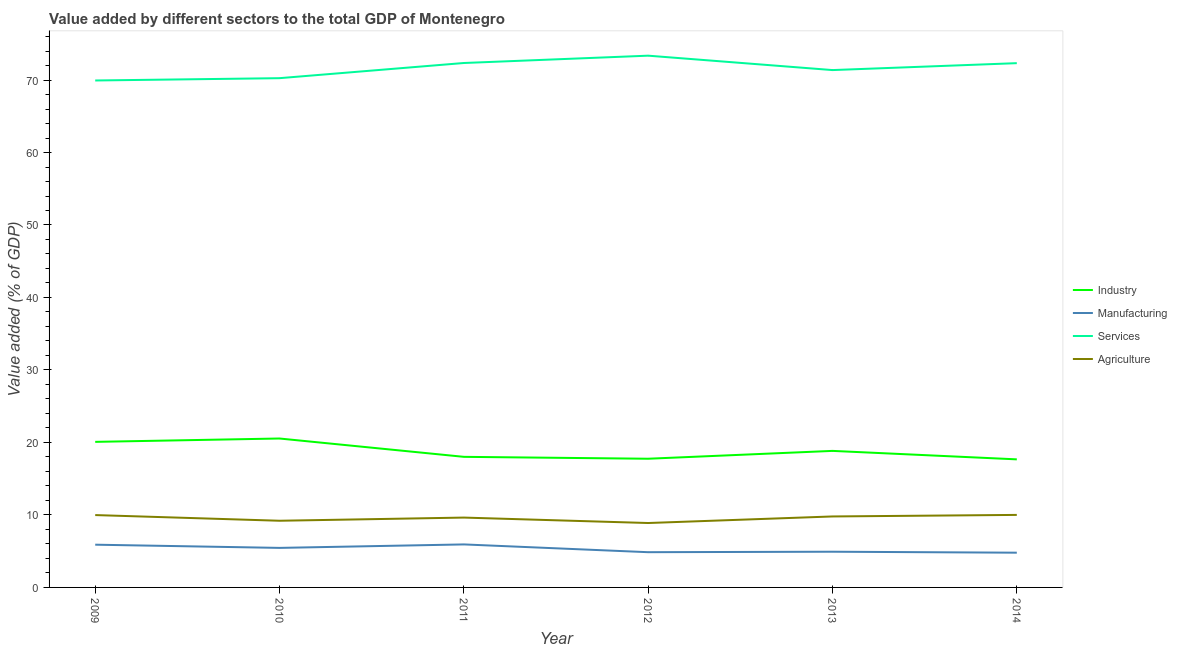What is the value added by industrial sector in 2012?
Keep it short and to the point. 17.75. Across all years, what is the maximum value added by services sector?
Make the answer very short. 73.36. Across all years, what is the minimum value added by services sector?
Offer a very short reply. 69.94. In which year was the value added by services sector minimum?
Give a very brief answer. 2009. What is the total value added by agricultural sector in the graph?
Your answer should be very brief. 57.5. What is the difference between the value added by industrial sector in 2009 and that in 2010?
Your answer should be compact. -0.46. What is the difference between the value added by industrial sector in 2010 and the value added by services sector in 2013?
Provide a short and direct response. -50.83. What is the average value added by services sector per year?
Your response must be concise. 71.6. In the year 2011, what is the difference between the value added by services sector and value added by manufacturing sector?
Ensure brevity in your answer.  66.42. In how many years, is the value added by agricultural sector greater than 58 %?
Your answer should be compact. 0. What is the ratio of the value added by manufacturing sector in 2012 to that in 2014?
Provide a succinct answer. 1.01. Is the value added by industrial sector in 2011 less than that in 2013?
Provide a succinct answer. Yes. What is the difference between the highest and the second highest value added by industrial sector?
Your answer should be very brief. 0.46. What is the difference between the highest and the lowest value added by agricultural sector?
Provide a short and direct response. 1.12. In how many years, is the value added by services sector greater than the average value added by services sector taken over all years?
Offer a terse response. 3. Is the sum of the value added by agricultural sector in 2010 and 2011 greater than the maximum value added by services sector across all years?
Provide a succinct answer. No. Does the value added by agricultural sector monotonically increase over the years?
Offer a very short reply. No. Is the value added by manufacturing sector strictly greater than the value added by industrial sector over the years?
Offer a very short reply. No. How many years are there in the graph?
Ensure brevity in your answer.  6. Are the values on the major ticks of Y-axis written in scientific E-notation?
Provide a succinct answer. No. Does the graph contain grids?
Provide a succinct answer. No. Where does the legend appear in the graph?
Provide a short and direct response. Center right. What is the title of the graph?
Make the answer very short. Value added by different sectors to the total GDP of Montenegro. What is the label or title of the Y-axis?
Offer a terse response. Value added (% of GDP). What is the Value added (% of GDP) of Industry in 2009?
Provide a succinct answer. 20.08. What is the Value added (% of GDP) in Manufacturing in 2009?
Offer a very short reply. 5.9. What is the Value added (% of GDP) in Services in 2009?
Offer a terse response. 69.94. What is the Value added (% of GDP) in Agriculture in 2009?
Your answer should be compact. 9.98. What is the Value added (% of GDP) in Industry in 2010?
Make the answer very short. 20.54. What is the Value added (% of GDP) in Manufacturing in 2010?
Your answer should be very brief. 5.45. What is the Value added (% of GDP) in Services in 2010?
Your answer should be compact. 70.26. What is the Value added (% of GDP) of Agriculture in 2010?
Ensure brevity in your answer.  9.2. What is the Value added (% of GDP) in Industry in 2011?
Offer a very short reply. 18.02. What is the Value added (% of GDP) in Manufacturing in 2011?
Your answer should be compact. 5.93. What is the Value added (% of GDP) of Services in 2011?
Your response must be concise. 72.35. What is the Value added (% of GDP) in Agriculture in 2011?
Provide a succinct answer. 9.64. What is the Value added (% of GDP) of Industry in 2012?
Your response must be concise. 17.75. What is the Value added (% of GDP) in Manufacturing in 2012?
Offer a very short reply. 4.86. What is the Value added (% of GDP) in Services in 2012?
Provide a succinct answer. 73.36. What is the Value added (% of GDP) in Agriculture in 2012?
Your answer should be compact. 8.89. What is the Value added (% of GDP) of Industry in 2013?
Offer a very short reply. 18.84. What is the Value added (% of GDP) of Manufacturing in 2013?
Offer a very short reply. 4.93. What is the Value added (% of GDP) of Services in 2013?
Ensure brevity in your answer.  71.37. What is the Value added (% of GDP) of Agriculture in 2013?
Keep it short and to the point. 9.79. What is the Value added (% of GDP) in Industry in 2014?
Keep it short and to the point. 17.67. What is the Value added (% of GDP) of Manufacturing in 2014?
Offer a very short reply. 4.79. What is the Value added (% of GDP) of Services in 2014?
Your answer should be compact. 72.33. What is the Value added (% of GDP) in Agriculture in 2014?
Provide a short and direct response. 10.01. Across all years, what is the maximum Value added (% of GDP) in Industry?
Make the answer very short. 20.54. Across all years, what is the maximum Value added (% of GDP) in Manufacturing?
Make the answer very short. 5.93. Across all years, what is the maximum Value added (% of GDP) in Services?
Keep it short and to the point. 73.36. Across all years, what is the maximum Value added (% of GDP) in Agriculture?
Provide a succinct answer. 10.01. Across all years, what is the minimum Value added (% of GDP) of Industry?
Your answer should be compact. 17.67. Across all years, what is the minimum Value added (% of GDP) of Manufacturing?
Offer a terse response. 4.79. Across all years, what is the minimum Value added (% of GDP) of Services?
Give a very brief answer. 69.94. Across all years, what is the minimum Value added (% of GDP) of Agriculture?
Provide a short and direct response. 8.89. What is the total Value added (% of GDP) in Industry in the graph?
Offer a terse response. 112.9. What is the total Value added (% of GDP) of Manufacturing in the graph?
Give a very brief answer. 31.86. What is the total Value added (% of GDP) in Services in the graph?
Offer a terse response. 429.6. What is the total Value added (% of GDP) in Agriculture in the graph?
Your response must be concise. 57.5. What is the difference between the Value added (% of GDP) in Industry in 2009 and that in 2010?
Make the answer very short. -0.46. What is the difference between the Value added (% of GDP) of Manufacturing in 2009 and that in 2010?
Your answer should be compact. 0.44. What is the difference between the Value added (% of GDP) of Services in 2009 and that in 2010?
Ensure brevity in your answer.  -0.32. What is the difference between the Value added (% of GDP) of Agriculture in 2009 and that in 2010?
Ensure brevity in your answer.  0.78. What is the difference between the Value added (% of GDP) in Industry in 2009 and that in 2011?
Your answer should be compact. 2.07. What is the difference between the Value added (% of GDP) of Manufacturing in 2009 and that in 2011?
Give a very brief answer. -0.04. What is the difference between the Value added (% of GDP) in Services in 2009 and that in 2011?
Provide a succinct answer. -2.41. What is the difference between the Value added (% of GDP) in Agriculture in 2009 and that in 2011?
Your answer should be compact. 0.35. What is the difference between the Value added (% of GDP) of Industry in 2009 and that in 2012?
Ensure brevity in your answer.  2.33. What is the difference between the Value added (% of GDP) of Manufacturing in 2009 and that in 2012?
Make the answer very short. 1.04. What is the difference between the Value added (% of GDP) in Services in 2009 and that in 2012?
Give a very brief answer. -3.42. What is the difference between the Value added (% of GDP) of Agriculture in 2009 and that in 2012?
Offer a terse response. 1.1. What is the difference between the Value added (% of GDP) in Industry in 2009 and that in 2013?
Provide a short and direct response. 1.24. What is the difference between the Value added (% of GDP) in Manufacturing in 2009 and that in 2013?
Make the answer very short. 0.97. What is the difference between the Value added (% of GDP) of Services in 2009 and that in 2013?
Your answer should be compact. -1.44. What is the difference between the Value added (% of GDP) in Agriculture in 2009 and that in 2013?
Provide a succinct answer. 0.19. What is the difference between the Value added (% of GDP) of Industry in 2009 and that in 2014?
Your response must be concise. 2.41. What is the difference between the Value added (% of GDP) of Manufacturing in 2009 and that in 2014?
Provide a succinct answer. 1.1. What is the difference between the Value added (% of GDP) in Services in 2009 and that in 2014?
Your answer should be compact. -2.39. What is the difference between the Value added (% of GDP) of Agriculture in 2009 and that in 2014?
Your answer should be compact. -0.02. What is the difference between the Value added (% of GDP) in Industry in 2010 and that in 2011?
Give a very brief answer. 2.53. What is the difference between the Value added (% of GDP) of Manufacturing in 2010 and that in 2011?
Ensure brevity in your answer.  -0.48. What is the difference between the Value added (% of GDP) in Services in 2010 and that in 2011?
Provide a succinct answer. -2.09. What is the difference between the Value added (% of GDP) in Agriculture in 2010 and that in 2011?
Your answer should be compact. -0.44. What is the difference between the Value added (% of GDP) in Industry in 2010 and that in 2012?
Your response must be concise. 2.79. What is the difference between the Value added (% of GDP) of Manufacturing in 2010 and that in 2012?
Offer a very short reply. 0.59. What is the difference between the Value added (% of GDP) in Services in 2010 and that in 2012?
Your answer should be very brief. -3.1. What is the difference between the Value added (% of GDP) of Agriculture in 2010 and that in 2012?
Your response must be concise. 0.31. What is the difference between the Value added (% of GDP) of Industry in 2010 and that in 2013?
Keep it short and to the point. 1.71. What is the difference between the Value added (% of GDP) in Manufacturing in 2010 and that in 2013?
Ensure brevity in your answer.  0.53. What is the difference between the Value added (% of GDP) in Services in 2010 and that in 2013?
Provide a succinct answer. -1.12. What is the difference between the Value added (% of GDP) of Agriculture in 2010 and that in 2013?
Make the answer very short. -0.59. What is the difference between the Value added (% of GDP) of Industry in 2010 and that in 2014?
Keep it short and to the point. 2.88. What is the difference between the Value added (% of GDP) of Manufacturing in 2010 and that in 2014?
Offer a very short reply. 0.66. What is the difference between the Value added (% of GDP) in Services in 2010 and that in 2014?
Ensure brevity in your answer.  -2.07. What is the difference between the Value added (% of GDP) in Agriculture in 2010 and that in 2014?
Offer a very short reply. -0.81. What is the difference between the Value added (% of GDP) in Industry in 2011 and that in 2012?
Your response must be concise. 0.26. What is the difference between the Value added (% of GDP) of Manufacturing in 2011 and that in 2012?
Provide a succinct answer. 1.07. What is the difference between the Value added (% of GDP) of Services in 2011 and that in 2012?
Provide a succinct answer. -1.01. What is the difference between the Value added (% of GDP) of Agriculture in 2011 and that in 2012?
Your answer should be compact. 0.75. What is the difference between the Value added (% of GDP) in Industry in 2011 and that in 2013?
Your answer should be compact. -0.82. What is the difference between the Value added (% of GDP) in Manufacturing in 2011 and that in 2013?
Keep it short and to the point. 1.01. What is the difference between the Value added (% of GDP) of Services in 2011 and that in 2013?
Provide a succinct answer. 0.98. What is the difference between the Value added (% of GDP) in Agriculture in 2011 and that in 2013?
Offer a terse response. -0.16. What is the difference between the Value added (% of GDP) in Industry in 2011 and that in 2014?
Keep it short and to the point. 0.35. What is the difference between the Value added (% of GDP) in Manufacturing in 2011 and that in 2014?
Your response must be concise. 1.14. What is the difference between the Value added (% of GDP) in Services in 2011 and that in 2014?
Offer a very short reply. 0.02. What is the difference between the Value added (% of GDP) in Agriculture in 2011 and that in 2014?
Your response must be concise. -0.37. What is the difference between the Value added (% of GDP) in Industry in 2012 and that in 2013?
Your response must be concise. -1.08. What is the difference between the Value added (% of GDP) in Manufacturing in 2012 and that in 2013?
Keep it short and to the point. -0.07. What is the difference between the Value added (% of GDP) of Services in 2012 and that in 2013?
Offer a terse response. 1.99. What is the difference between the Value added (% of GDP) in Agriculture in 2012 and that in 2013?
Your answer should be very brief. -0.91. What is the difference between the Value added (% of GDP) in Industry in 2012 and that in 2014?
Give a very brief answer. 0.09. What is the difference between the Value added (% of GDP) in Manufacturing in 2012 and that in 2014?
Your response must be concise. 0.07. What is the difference between the Value added (% of GDP) of Services in 2012 and that in 2014?
Make the answer very short. 1.03. What is the difference between the Value added (% of GDP) in Agriculture in 2012 and that in 2014?
Your answer should be compact. -1.12. What is the difference between the Value added (% of GDP) of Industry in 2013 and that in 2014?
Provide a succinct answer. 1.17. What is the difference between the Value added (% of GDP) of Manufacturing in 2013 and that in 2014?
Offer a terse response. 0.13. What is the difference between the Value added (% of GDP) in Services in 2013 and that in 2014?
Offer a terse response. -0.96. What is the difference between the Value added (% of GDP) of Agriculture in 2013 and that in 2014?
Offer a very short reply. -0.21. What is the difference between the Value added (% of GDP) of Industry in 2009 and the Value added (% of GDP) of Manufacturing in 2010?
Your response must be concise. 14.63. What is the difference between the Value added (% of GDP) in Industry in 2009 and the Value added (% of GDP) in Services in 2010?
Your answer should be compact. -50.18. What is the difference between the Value added (% of GDP) in Industry in 2009 and the Value added (% of GDP) in Agriculture in 2010?
Offer a terse response. 10.88. What is the difference between the Value added (% of GDP) of Manufacturing in 2009 and the Value added (% of GDP) of Services in 2010?
Provide a short and direct response. -64.36. What is the difference between the Value added (% of GDP) in Manufacturing in 2009 and the Value added (% of GDP) in Agriculture in 2010?
Make the answer very short. -3.3. What is the difference between the Value added (% of GDP) of Services in 2009 and the Value added (% of GDP) of Agriculture in 2010?
Provide a short and direct response. 60.74. What is the difference between the Value added (% of GDP) of Industry in 2009 and the Value added (% of GDP) of Manufacturing in 2011?
Your answer should be very brief. 14.15. What is the difference between the Value added (% of GDP) of Industry in 2009 and the Value added (% of GDP) of Services in 2011?
Your answer should be compact. -52.27. What is the difference between the Value added (% of GDP) in Industry in 2009 and the Value added (% of GDP) in Agriculture in 2011?
Your answer should be compact. 10.45. What is the difference between the Value added (% of GDP) of Manufacturing in 2009 and the Value added (% of GDP) of Services in 2011?
Offer a terse response. -66.45. What is the difference between the Value added (% of GDP) of Manufacturing in 2009 and the Value added (% of GDP) of Agriculture in 2011?
Your answer should be very brief. -3.74. What is the difference between the Value added (% of GDP) of Services in 2009 and the Value added (% of GDP) of Agriculture in 2011?
Offer a terse response. 60.3. What is the difference between the Value added (% of GDP) of Industry in 2009 and the Value added (% of GDP) of Manufacturing in 2012?
Provide a succinct answer. 15.22. What is the difference between the Value added (% of GDP) in Industry in 2009 and the Value added (% of GDP) in Services in 2012?
Keep it short and to the point. -53.28. What is the difference between the Value added (% of GDP) in Industry in 2009 and the Value added (% of GDP) in Agriculture in 2012?
Provide a short and direct response. 11.2. What is the difference between the Value added (% of GDP) of Manufacturing in 2009 and the Value added (% of GDP) of Services in 2012?
Your answer should be very brief. -67.46. What is the difference between the Value added (% of GDP) in Manufacturing in 2009 and the Value added (% of GDP) in Agriculture in 2012?
Your response must be concise. -2.99. What is the difference between the Value added (% of GDP) in Services in 2009 and the Value added (% of GDP) in Agriculture in 2012?
Make the answer very short. 61.05. What is the difference between the Value added (% of GDP) in Industry in 2009 and the Value added (% of GDP) in Manufacturing in 2013?
Keep it short and to the point. 15.15. What is the difference between the Value added (% of GDP) of Industry in 2009 and the Value added (% of GDP) of Services in 2013?
Provide a short and direct response. -51.29. What is the difference between the Value added (% of GDP) of Industry in 2009 and the Value added (% of GDP) of Agriculture in 2013?
Give a very brief answer. 10.29. What is the difference between the Value added (% of GDP) in Manufacturing in 2009 and the Value added (% of GDP) in Services in 2013?
Your response must be concise. -65.48. What is the difference between the Value added (% of GDP) in Manufacturing in 2009 and the Value added (% of GDP) in Agriculture in 2013?
Your response must be concise. -3.9. What is the difference between the Value added (% of GDP) of Services in 2009 and the Value added (% of GDP) of Agriculture in 2013?
Provide a short and direct response. 60.15. What is the difference between the Value added (% of GDP) in Industry in 2009 and the Value added (% of GDP) in Manufacturing in 2014?
Ensure brevity in your answer.  15.29. What is the difference between the Value added (% of GDP) of Industry in 2009 and the Value added (% of GDP) of Services in 2014?
Your response must be concise. -52.25. What is the difference between the Value added (% of GDP) in Industry in 2009 and the Value added (% of GDP) in Agriculture in 2014?
Provide a short and direct response. 10.08. What is the difference between the Value added (% of GDP) in Manufacturing in 2009 and the Value added (% of GDP) in Services in 2014?
Make the answer very short. -66.43. What is the difference between the Value added (% of GDP) of Manufacturing in 2009 and the Value added (% of GDP) of Agriculture in 2014?
Offer a very short reply. -4.11. What is the difference between the Value added (% of GDP) of Services in 2009 and the Value added (% of GDP) of Agriculture in 2014?
Make the answer very short. 59.93. What is the difference between the Value added (% of GDP) in Industry in 2010 and the Value added (% of GDP) in Manufacturing in 2011?
Offer a terse response. 14.61. What is the difference between the Value added (% of GDP) in Industry in 2010 and the Value added (% of GDP) in Services in 2011?
Offer a terse response. -51.8. What is the difference between the Value added (% of GDP) in Industry in 2010 and the Value added (% of GDP) in Agriculture in 2011?
Your response must be concise. 10.91. What is the difference between the Value added (% of GDP) of Manufacturing in 2010 and the Value added (% of GDP) of Services in 2011?
Provide a succinct answer. -66.89. What is the difference between the Value added (% of GDP) in Manufacturing in 2010 and the Value added (% of GDP) in Agriculture in 2011?
Offer a very short reply. -4.18. What is the difference between the Value added (% of GDP) of Services in 2010 and the Value added (% of GDP) of Agriculture in 2011?
Ensure brevity in your answer.  60.62. What is the difference between the Value added (% of GDP) of Industry in 2010 and the Value added (% of GDP) of Manufacturing in 2012?
Your response must be concise. 15.68. What is the difference between the Value added (% of GDP) in Industry in 2010 and the Value added (% of GDP) in Services in 2012?
Offer a very short reply. -52.81. What is the difference between the Value added (% of GDP) of Industry in 2010 and the Value added (% of GDP) of Agriculture in 2012?
Provide a succinct answer. 11.66. What is the difference between the Value added (% of GDP) in Manufacturing in 2010 and the Value added (% of GDP) in Services in 2012?
Provide a succinct answer. -67.9. What is the difference between the Value added (% of GDP) in Manufacturing in 2010 and the Value added (% of GDP) in Agriculture in 2012?
Offer a very short reply. -3.43. What is the difference between the Value added (% of GDP) in Services in 2010 and the Value added (% of GDP) in Agriculture in 2012?
Your answer should be very brief. 61.37. What is the difference between the Value added (% of GDP) of Industry in 2010 and the Value added (% of GDP) of Manufacturing in 2013?
Provide a short and direct response. 15.62. What is the difference between the Value added (% of GDP) of Industry in 2010 and the Value added (% of GDP) of Services in 2013?
Provide a short and direct response. -50.83. What is the difference between the Value added (% of GDP) of Industry in 2010 and the Value added (% of GDP) of Agriculture in 2013?
Give a very brief answer. 10.75. What is the difference between the Value added (% of GDP) in Manufacturing in 2010 and the Value added (% of GDP) in Services in 2013?
Your answer should be very brief. -65.92. What is the difference between the Value added (% of GDP) in Manufacturing in 2010 and the Value added (% of GDP) in Agriculture in 2013?
Your answer should be compact. -4.34. What is the difference between the Value added (% of GDP) in Services in 2010 and the Value added (% of GDP) in Agriculture in 2013?
Your response must be concise. 60.47. What is the difference between the Value added (% of GDP) in Industry in 2010 and the Value added (% of GDP) in Manufacturing in 2014?
Your answer should be compact. 15.75. What is the difference between the Value added (% of GDP) of Industry in 2010 and the Value added (% of GDP) of Services in 2014?
Provide a succinct answer. -51.78. What is the difference between the Value added (% of GDP) of Industry in 2010 and the Value added (% of GDP) of Agriculture in 2014?
Make the answer very short. 10.54. What is the difference between the Value added (% of GDP) in Manufacturing in 2010 and the Value added (% of GDP) in Services in 2014?
Offer a terse response. -66.87. What is the difference between the Value added (% of GDP) in Manufacturing in 2010 and the Value added (% of GDP) in Agriculture in 2014?
Your answer should be very brief. -4.55. What is the difference between the Value added (% of GDP) of Services in 2010 and the Value added (% of GDP) of Agriculture in 2014?
Offer a very short reply. 60.25. What is the difference between the Value added (% of GDP) in Industry in 2011 and the Value added (% of GDP) in Manufacturing in 2012?
Keep it short and to the point. 13.16. What is the difference between the Value added (% of GDP) in Industry in 2011 and the Value added (% of GDP) in Services in 2012?
Make the answer very short. -55.34. What is the difference between the Value added (% of GDP) of Industry in 2011 and the Value added (% of GDP) of Agriculture in 2012?
Give a very brief answer. 9.13. What is the difference between the Value added (% of GDP) in Manufacturing in 2011 and the Value added (% of GDP) in Services in 2012?
Your answer should be compact. -67.43. What is the difference between the Value added (% of GDP) in Manufacturing in 2011 and the Value added (% of GDP) in Agriculture in 2012?
Make the answer very short. -2.95. What is the difference between the Value added (% of GDP) of Services in 2011 and the Value added (% of GDP) of Agriculture in 2012?
Provide a succinct answer. 63.46. What is the difference between the Value added (% of GDP) in Industry in 2011 and the Value added (% of GDP) in Manufacturing in 2013?
Offer a very short reply. 13.09. What is the difference between the Value added (% of GDP) of Industry in 2011 and the Value added (% of GDP) of Services in 2013?
Your response must be concise. -53.36. What is the difference between the Value added (% of GDP) of Industry in 2011 and the Value added (% of GDP) of Agriculture in 2013?
Give a very brief answer. 8.22. What is the difference between the Value added (% of GDP) of Manufacturing in 2011 and the Value added (% of GDP) of Services in 2013?
Offer a terse response. -65.44. What is the difference between the Value added (% of GDP) of Manufacturing in 2011 and the Value added (% of GDP) of Agriculture in 2013?
Your response must be concise. -3.86. What is the difference between the Value added (% of GDP) in Services in 2011 and the Value added (% of GDP) in Agriculture in 2013?
Provide a short and direct response. 62.56. What is the difference between the Value added (% of GDP) in Industry in 2011 and the Value added (% of GDP) in Manufacturing in 2014?
Provide a succinct answer. 13.22. What is the difference between the Value added (% of GDP) of Industry in 2011 and the Value added (% of GDP) of Services in 2014?
Offer a very short reply. -54.31. What is the difference between the Value added (% of GDP) of Industry in 2011 and the Value added (% of GDP) of Agriculture in 2014?
Provide a succinct answer. 8.01. What is the difference between the Value added (% of GDP) in Manufacturing in 2011 and the Value added (% of GDP) in Services in 2014?
Make the answer very short. -66.39. What is the difference between the Value added (% of GDP) in Manufacturing in 2011 and the Value added (% of GDP) in Agriculture in 2014?
Your response must be concise. -4.07. What is the difference between the Value added (% of GDP) of Services in 2011 and the Value added (% of GDP) of Agriculture in 2014?
Make the answer very short. 62.34. What is the difference between the Value added (% of GDP) in Industry in 2012 and the Value added (% of GDP) in Manufacturing in 2013?
Make the answer very short. 12.83. What is the difference between the Value added (% of GDP) in Industry in 2012 and the Value added (% of GDP) in Services in 2013?
Provide a short and direct response. -53.62. What is the difference between the Value added (% of GDP) of Industry in 2012 and the Value added (% of GDP) of Agriculture in 2013?
Keep it short and to the point. 7.96. What is the difference between the Value added (% of GDP) in Manufacturing in 2012 and the Value added (% of GDP) in Services in 2013?
Your response must be concise. -66.51. What is the difference between the Value added (% of GDP) in Manufacturing in 2012 and the Value added (% of GDP) in Agriculture in 2013?
Offer a very short reply. -4.93. What is the difference between the Value added (% of GDP) of Services in 2012 and the Value added (% of GDP) of Agriculture in 2013?
Provide a short and direct response. 63.57. What is the difference between the Value added (% of GDP) in Industry in 2012 and the Value added (% of GDP) in Manufacturing in 2014?
Your answer should be very brief. 12.96. What is the difference between the Value added (% of GDP) of Industry in 2012 and the Value added (% of GDP) of Services in 2014?
Your answer should be very brief. -54.57. What is the difference between the Value added (% of GDP) of Industry in 2012 and the Value added (% of GDP) of Agriculture in 2014?
Your response must be concise. 7.75. What is the difference between the Value added (% of GDP) of Manufacturing in 2012 and the Value added (% of GDP) of Services in 2014?
Your answer should be very brief. -67.47. What is the difference between the Value added (% of GDP) of Manufacturing in 2012 and the Value added (% of GDP) of Agriculture in 2014?
Ensure brevity in your answer.  -5.14. What is the difference between the Value added (% of GDP) in Services in 2012 and the Value added (% of GDP) in Agriculture in 2014?
Ensure brevity in your answer.  63.35. What is the difference between the Value added (% of GDP) of Industry in 2013 and the Value added (% of GDP) of Manufacturing in 2014?
Your answer should be very brief. 14.04. What is the difference between the Value added (% of GDP) in Industry in 2013 and the Value added (% of GDP) in Services in 2014?
Provide a succinct answer. -53.49. What is the difference between the Value added (% of GDP) in Industry in 2013 and the Value added (% of GDP) in Agriculture in 2014?
Keep it short and to the point. 8.83. What is the difference between the Value added (% of GDP) of Manufacturing in 2013 and the Value added (% of GDP) of Services in 2014?
Give a very brief answer. -67.4. What is the difference between the Value added (% of GDP) in Manufacturing in 2013 and the Value added (% of GDP) in Agriculture in 2014?
Give a very brief answer. -5.08. What is the difference between the Value added (% of GDP) in Services in 2013 and the Value added (% of GDP) in Agriculture in 2014?
Your answer should be compact. 61.37. What is the average Value added (% of GDP) of Industry per year?
Your answer should be very brief. 18.82. What is the average Value added (% of GDP) of Manufacturing per year?
Offer a terse response. 5.31. What is the average Value added (% of GDP) of Services per year?
Your answer should be compact. 71.6. What is the average Value added (% of GDP) of Agriculture per year?
Offer a terse response. 9.58. In the year 2009, what is the difference between the Value added (% of GDP) of Industry and Value added (% of GDP) of Manufacturing?
Give a very brief answer. 14.18. In the year 2009, what is the difference between the Value added (% of GDP) in Industry and Value added (% of GDP) in Services?
Ensure brevity in your answer.  -49.86. In the year 2009, what is the difference between the Value added (% of GDP) in Industry and Value added (% of GDP) in Agriculture?
Make the answer very short. 10.1. In the year 2009, what is the difference between the Value added (% of GDP) in Manufacturing and Value added (% of GDP) in Services?
Offer a terse response. -64.04. In the year 2009, what is the difference between the Value added (% of GDP) in Manufacturing and Value added (% of GDP) in Agriculture?
Offer a very short reply. -4.09. In the year 2009, what is the difference between the Value added (% of GDP) in Services and Value added (% of GDP) in Agriculture?
Keep it short and to the point. 59.95. In the year 2010, what is the difference between the Value added (% of GDP) in Industry and Value added (% of GDP) in Manufacturing?
Your answer should be very brief. 15.09. In the year 2010, what is the difference between the Value added (% of GDP) of Industry and Value added (% of GDP) of Services?
Your answer should be very brief. -49.71. In the year 2010, what is the difference between the Value added (% of GDP) in Industry and Value added (% of GDP) in Agriculture?
Keep it short and to the point. 11.35. In the year 2010, what is the difference between the Value added (% of GDP) of Manufacturing and Value added (% of GDP) of Services?
Your response must be concise. -64.8. In the year 2010, what is the difference between the Value added (% of GDP) in Manufacturing and Value added (% of GDP) in Agriculture?
Offer a very short reply. -3.74. In the year 2010, what is the difference between the Value added (% of GDP) in Services and Value added (% of GDP) in Agriculture?
Keep it short and to the point. 61.06. In the year 2011, what is the difference between the Value added (% of GDP) of Industry and Value added (% of GDP) of Manufacturing?
Your answer should be compact. 12.08. In the year 2011, what is the difference between the Value added (% of GDP) in Industry and Value added (% of GDP) in Services?
Offer a terse response. -54.33. In the year 2011, what is the difference between the Value added (% of GDP) of Industry and Value added (% of GDP) of Agriculture?
Ensure brevity in your answer.  8.38. In the year 2011, what is the difference between the Value added (% of GDP) in Manufacturing and Value added (% of GDP) in Services?
Give a very brief answer. -66.42. In the year 2011, what is the difference between the Value added (% of GDP) in Manufacturing and Value added (% of GDP) in Agriculture?
Your answer should be compact. -3.7. In the year 2011, what is the difference between the Value added (% of GDP) of Services and Value added (% of GDP) of Agriculture?
Offer a very short reply. 62.71. In the year 2012, what is the difference between the Value added (% of GDP) in Industry and Value added (% of GDP) in Manufacturing?
Make the answer very short. 12.89. In the year 2012, what is the difference between the Value added (% of GDP) in Industry and Value added (% of GDP) in Services?
Offer a terse response. -55.6. In the year 2012, what is the difference between the Value added (% of GDP) of Industry and Value added (% of GDP) of Agriculture?
Keep it short and to the point. 8.87. In the year 2012, what is the difference between the Value added (% of GDP) of Manufacturing and Value added (% of GDP) of Services?
Offer a terse response. -68.5. In the year 2012, what is the difference between the Value added (% of GDP) in Manufacturing and Value added (% of GDP) in Agriculture?
Ensure brevity in your answer.  -4.03. In the year 2012, what is the difference between the Value added (% of GDP) in Services and Value added (% of GDP) in Agriculture?
Give a very brief answer. 64.47. In the year 2013, what is the difference between the Value added (% of GDP) of Industry and Value added (% of GDP) of Manufacturing?
Your response must be concise. 13.91. In the year 2013, what is the difference between the Value added (% of GDP) of Industry and Value added (% of GDP) of Services?
Provide a succinct answer. -52.53. In the year 2013, what is the difference between the Value added (% of GDP) in Industry and Value added (% of GDP) in Agriculture?
Give a very brief answer. 9.05. In the year 2013, what is the difference between the Value added (% of GDP) in Manufacturing and Value added (% of GDP) in Services?
Your response must be concise. -66.44. In the year 2013, what is the difference between the Value added (% of GDP) of Manufacturing and Value added (% of GDP) of Agriculture?
Provide a short and direct response. -4.86. In the year 2013, what is the difference between the Value added (% of GDP) of Services and Value added (% of GDP) of Agriculture?
Offer a terse response. 61.58. In the year 2014, what is the difference between the Value added (% of GDP) in Industry and Value added (% of GDP) in Manufacturing?
Provide a succinct answer. 12.88. In the year 2014, what is the difference between the Value added (% of GDP) of Industry and Value added (% of GDP) of Services?
Your answer should be compact. -54.66. In the year 2014, what is the difference between the Value added (% of GDP) of Industry and Value added (% of GDP) of Agriculture?
Your answer should be very brief. 7.66. In the year 2014, what is the difference between the Value added (% of GDP) in Manufacturing and Value added (% of GDP) in Services?
Ensure brevity in your answer.  -67.53. In the year 2014, what is the difference between the Value added (% of GDP) in Manufacturing and Value added (% of GDP) in Agriculture?
Your answer should be very brief. -5.21. In the year 2014, what is the difference between the Value added (% of GDP) of Services and Value added (% of GDP) of Agriculture?
Keep it short and to the point. 62.32. What is the ratio of the Value added (% of GDP) of Industry in 2009 to that in 2010?
Ensure brevity in your answer.  0.98. What is the ratio of the Value added (% of GDP) in Manufacturing in 2009 to that in 2010?
Offer a terse response. 1.08. What is the ratio of the Value added (% of GDP) of Agriculture in 2009 to that in 2010?
Offer a terse response. 1.09. What is the ratio of the Value added (% of GDP) of Industry in 2009 to that in 2011?
Your answer should be very brief. 1.11. What is the ratio of the Value added (% of GDP) of Services in 2009 to that in 2011?
Offer a terse response. 0.97. What is the ratio of the Value added (% of GDP) of Agriculture in 2009 to that in 2011?
Your response must be concise. 1.04. What is the ratio of the Value added (% of GDP) in Industry in 2009 to that in 2012?
Provide a succinct answer. 1.13. What is the ratio of the Value added (% of GDP) in Manufacturing in 2009 to that in 2012?
Provide a short and direct response. 1.21. What is the ratio of the Value added (% of GDP) of Services in 2009 to that in 2012?
Give a very brief answer. 0.95. What is the ratio of the Value added (% of GDP) in Agriculture in 2009 to that in 2012?
Provide a short and direct response. 1.12. What is the ratio of the Value added (% of GDP) in Industry in 2009 to that in 2013?
Your answer should be very brief. 1.07. What is the ratio of the Value added (% of GDP) of Manufacturing in 2009 to that in 2013?
Offer a terse response. 1.2. What is the ratio of the Value added (% of GDP) in Services in 2009 to that in 2013?
Your answer should be compact. 0.98. What is the ratio of the Value added (% of GDP) in Agriculture in 2009 to that in 2013?
Offer a very short reply. 1.02. What is the ratio of the Value added (% of GDP) of Industry in 2009 to that in 2014?
Give a very brief answer. 1.14. What is the ratio of the Value added (% of GDP) of Manufacturing in 2009 to that in 2014?
Offer a terse response. 1.23. What is the ratio of the Value added (% of GDP) in Services in 2009 to that in 2014?
Your answer should be compact. 0.97. What is the ratio of the Value added (% of GDP) of Agriculture in 2009 to that in 2014?
Ensure brevity in your answer.  1. What is the ratio of the Value added (% of GDP) of Industry in 2010 to that in 2011?
Your answer should be compact. 1.14. What is the ratio of the Value added (% of GDP) in Manufacturing in 2010 to that in 2011?
Your answer should be compact. 0.92. What is the ratio of the Value added (% of GDP) in Services in 2010 to that in 2011?
Give a very brief answer. 0.97. What is the ratio of the Value added (% of GDP) of Agriculture in 2010 to that in 2011?
Your answer should be very brief. 0.95. What is the ratio of the Value added (% of GDP) in Industry in 2010 to that in 2012?
Your answer should be very brief. 1.16. What is the ratio of the Value added (% of GDP) of Manufacturing in 2010 to that in 2012?
Ensure brevity in your answer.  1.12. What is the ratio of the Value added (% of GDP) in Services in 2010 to that in 2012?
Your answer should be very brief. 0.96. What is the ratio of the Value added (% of GDP) in Agriculture in 2010 to that in 2012?
Provide a succinct answer. 1.04. What is the ratio of the Value added (% of GDP) in Industry in 2010 to that in 2013?
Keep it short and to the point. 1.09. What is the ratio of the Value added (% of GDP) in Manufacturing in 2010 to that in 2013?
Keep it short and to the point. 1.11. What is the ratio of the Value added (% of GDP) of Services in 2010 to that in 2013?
Make the answer very short. 0.98. What is the ratio of the Value added (% of GDP) in Agriculture in 2010 to that in 2013?
Your answer should be very brief. 0.94. What is the ratio of the Value added (% of GDP) in Industry in 2010 to that in 2014?
Your response must be concise. 1.16. What is the ratio of the Value added (% of GDP) in Manufacturing in 2010 to that in 2014?
Provide a short and direct response. 1.14. What is the ratio of the Value added (% of GDP) in Services in 2010 to that in 2014?
Ensure brevity in your answer.  0.97. What is the ratio of the Value added (% of GDP) of Agriculture in 2010 to that in 2014?
Your response must be concise. 0.92. What is the ratio of the Value added (% of GDP) of Industry in 2011 to that in 2012?
Provide a short and direct response. 1.01. What is the ratio of the Value added (% of GDP) in Manufacturing in 2011 to that in 2012?
Your answer should be very brief. 1.22. What is the ratio of the Value added (% of GDP) of Services in 2011 to that in 2012?
Your response must be concise. 0.99. What is the ratio of the Value added (% of GDP) in Agriculture in 2011 to that in 2012?
Make the answer very short. 1.08. What is the ratio of the Value added (% of GDP) in Industry in 2011 to that in 2013?
Your answer should be very brief. 0.96. What is the ratio of the Value added (% of GDP) in Manufacturing in 2011 to that in 2013?
Make the answer very short. 1.2. What is the ratio of the Value added (% of GDP) in Services in 2011 to that in 2013?
Your answer should be compact. 1.01. What is the ratio of the Value added (% of GDP) in Agriculture in 2011 to that in 2013?
Your response must be concise. 0.98. What is the ratio of the Value added (% of GDP) of Industry in 2011 to that in 2014?
Give a very brief answer. 1.02. What is the ratio of the Value added (% of GDP) in Manufacturing in 2011 to that in 2014?
Your response must be concise. 1.24. What is the ratio of the Value added (% of GDP) in Agriculture in 2011 to that in 2014?
Ensure brevity in your answer.  0.96. What is the ratio of the Value added (% of GDP) in Industry in 2012 to that in 2013?
Provide a succinct answer. 0.94. What is the ratio of the Value added (% of GDP) in Manufacturing in 2012 to that in 2013?
Offer a terse response. 0.99. What is the ratio of the Value added (% of GDP) in Services in 2012 to that in 2013?
Provide a succinct answer. 1.03. What is the ratio of the Value added (% of GDP) of Agriculture in 2012 to that in 2013?
Provide a short and direct response. 0.91. What is the ratio of the Value added (% of GDP) in Industry in 2012 to that in 2014?
Offer a terse response. 1. What is the ratio of the Value added (% of GDP) in Manufacturing in 2012 to that in 2014?
Your response must be concise. 1.01. What is the ratio of the Value added (% of GDP) in Services in 2012 to that in 2014?
Offer a terse response. 1.01. What is the ratio of the Value added (% of GDP) in Agriculture in 2012 to that in 2014?
Your answer should be compact. 0.89. What is the ratio of the Value added (% of GDP) in Industry in 2013 to that in 2014?
Provide a short and direct response. 1.07. What is the ratio of the Value added (% of GDP) in Manufacturing in 2013 to that in 2014?
Keep it short and to the point. 1.03. What is the ratio of the Value added (% of GDP) of Services in 2013 to that in 2014?
Ensure brevity in your answer.  0.99. What is the ratio of the Value added (% of GDP) of Agriculture in 2013 to that in 2014?
Your answer should be very brief. 0.98. What is the difference between the highest and the second highest Value added (% of GDP) of Industry?
Offer a very short reply. 0.46. What is the difference between the highest and the second highest Value added (% of GDP) in Manufacturing?
Offer a terse response. 0.04. What is the difference between the highest and the second highest Value added (% of GDP) of Services?
Provide a short and direct response. 1.01. What is the difference between the highest and the second highest Value added (% of GDP) in Agriculture?
Give a very brief answer. 0.02. What is the difference between the highest and the lowest Value added (% of GDP) in Industry?
Ensure brevity in your answer.  2.88. What is the difference between the highest and the lowest Value added (% of GDP) of Manufacturing?
Offer a very short reply. 1.14. What is the difference between the highest and the lowest Value added (% of GDP) of Services?
Your answer should be compact. 3.42. What is the difference between the highest and the lowest Value added (% of GDP) in Agriculture?
Your answer should be compact. 1.12. 